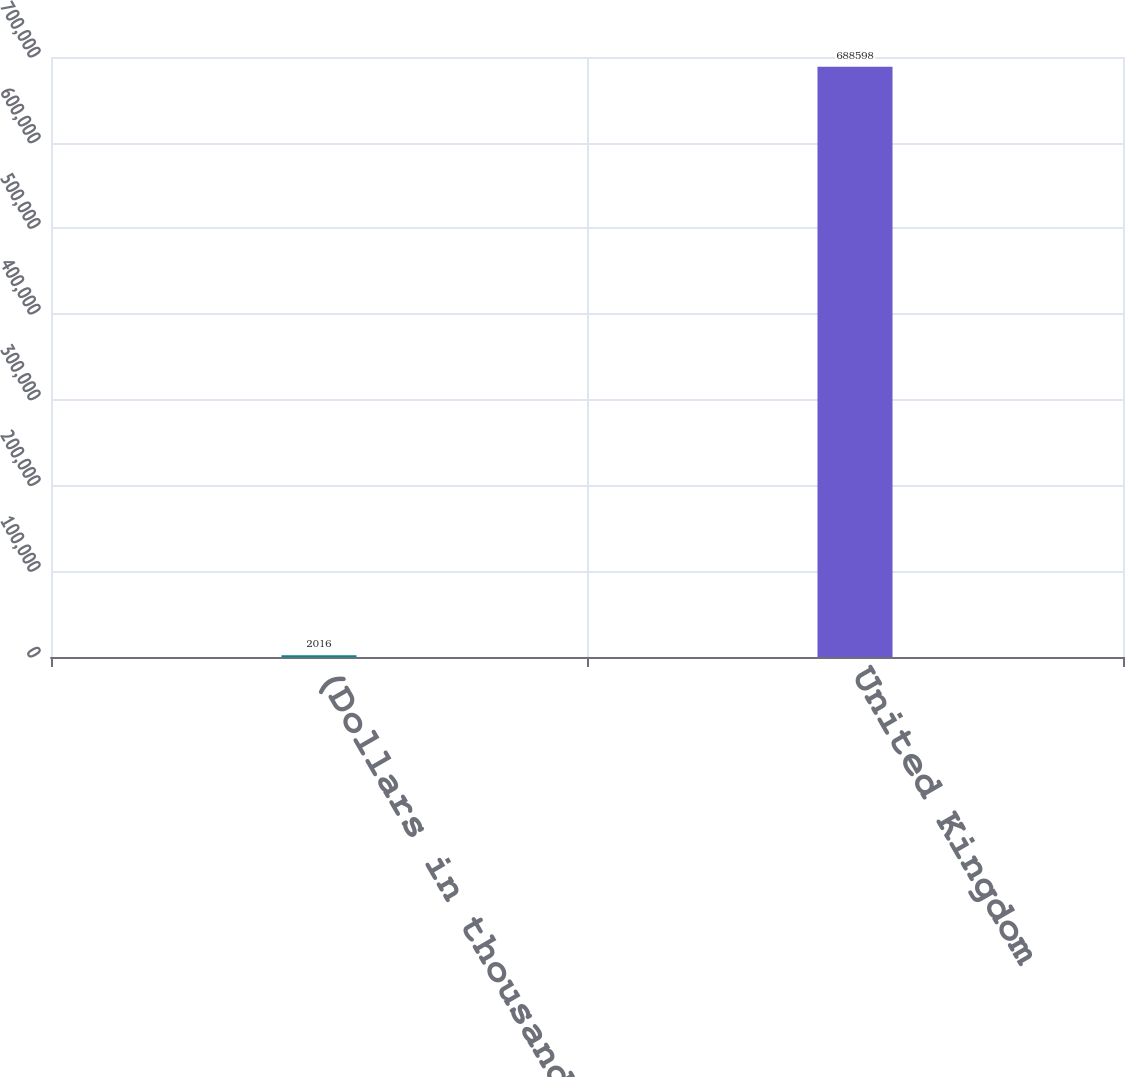<chart> <loc_0><loc_0><loc_500><loc_500><bar_chart><fcel>(Dollars in thousands)<fcel>United Kingdom<nl><fcel>2016<fcel>688598<nl></chart> 